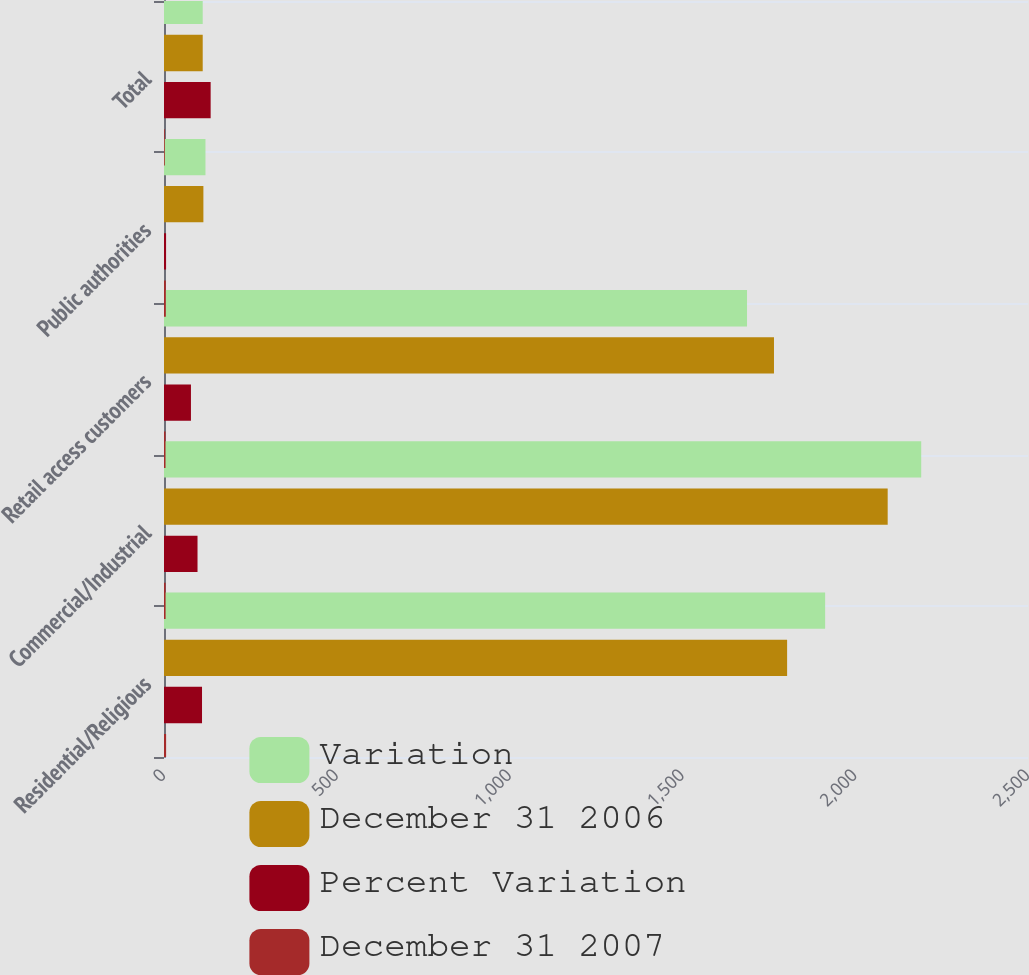<chart> <loc_0><loc_0><loc_500><loc_500><stacked_bar_chart><ecel><fcel>Residential/Religious<fcel>Commercial/Industrial<fcel>Retail access customers<fcel>Public authorities<fcel>Total<nl><fcel>Variation<fcel>1913<fcel>2191<fcel>1687<fcel>120<fcel>112<nl><fcel>December 31 2006<fcel>1803<fcel>2094<fcel>1765<fcel>114<fcel>112<nl><fcel>Percent Variation<fcel>110<fcel>97<fcel>78<fcel>6<fcel>135<nl><fcel>December 31 2007<fcel>6.1<fcel>4.6<fcel>4.4<fcel>5.3<fcel>2.3<nl></chart> 